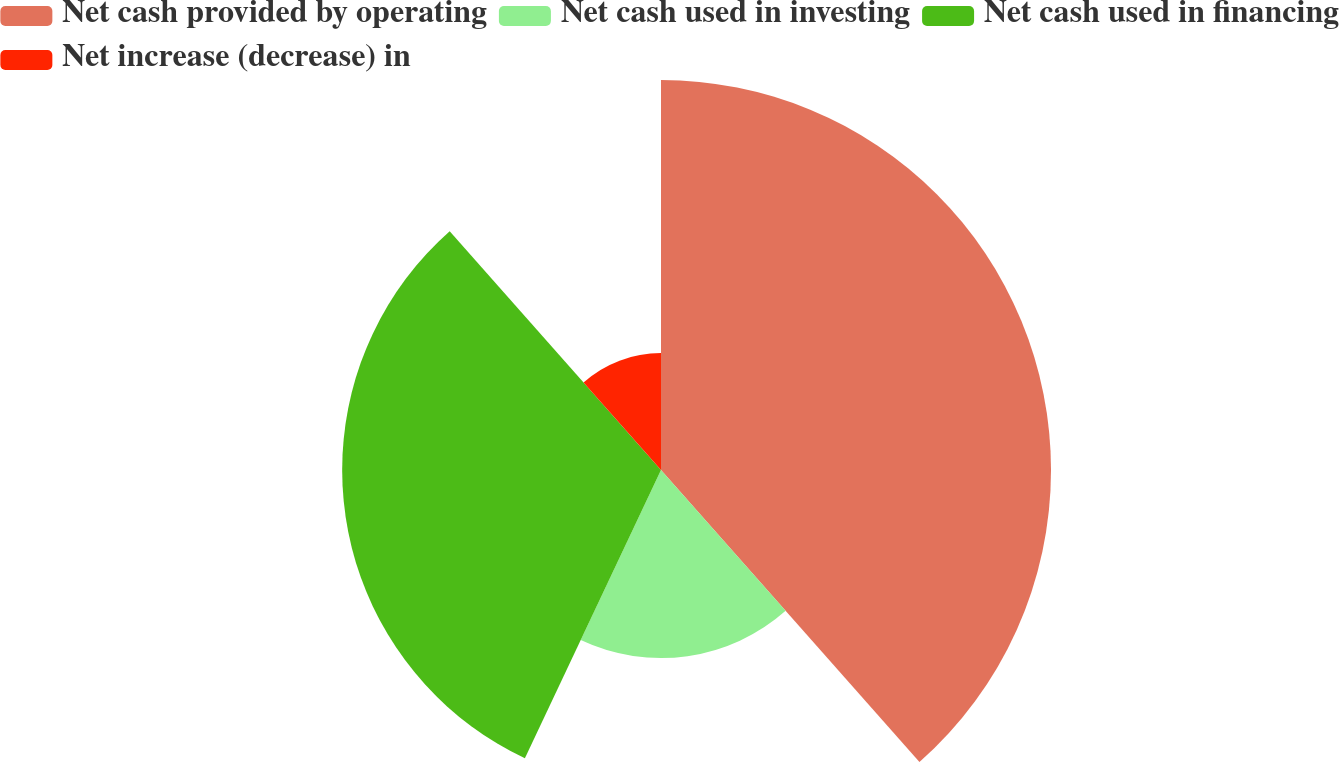Convert chart. <chart><loc_0><loc_0><loc_500><loc_500><pie_chart><fcel>Net cash provided by operating<fcel>Net cash used in investing<fcel>Net cash used in financing<fcel>Net increase (decrease) in<nl><fcel>38.47%<fcel>18.55%<fcel>31.45%<fcel>11.53%<nl></chart> 